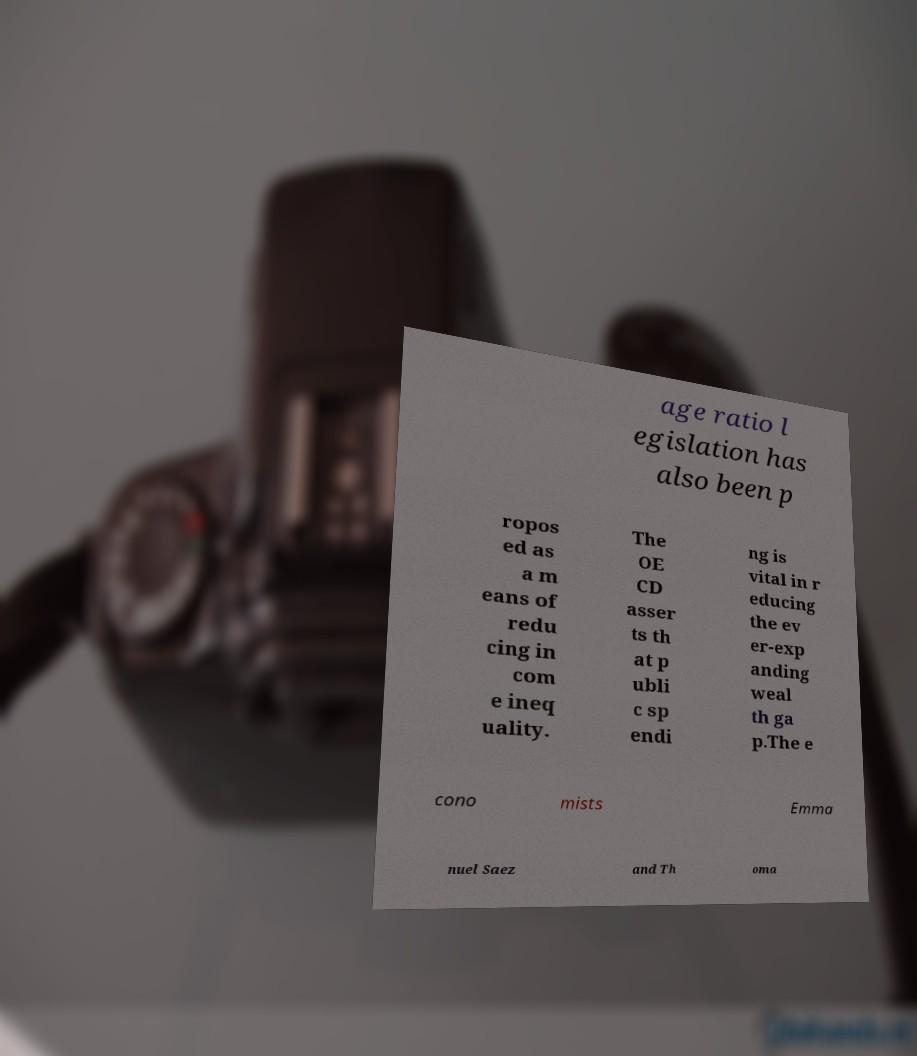Please identify and transcribe the text found in this image. age ratio l egislation has also been p ropos ed as a m eans of redu cing in com e ineq uality. The OE CD asser ts th at p ubli c sp endi ng is vital in r educing the ev er-exp anding weal th ga p.The e cono mists Emma nuel Saez and Th oma 